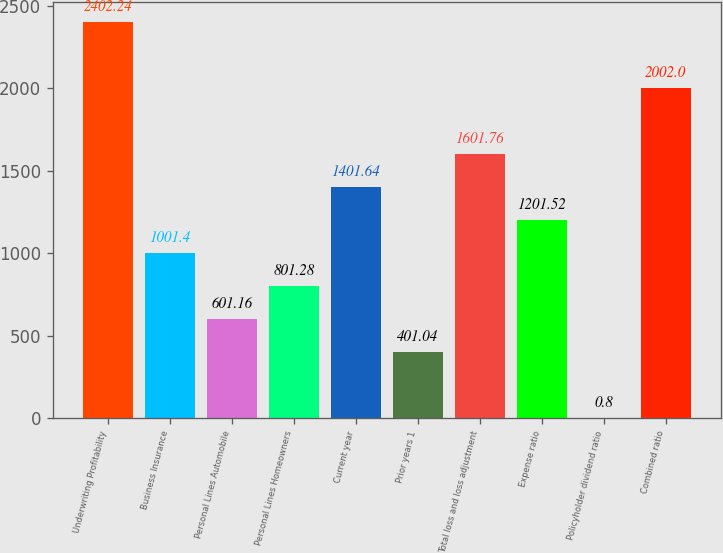Convert chart. <chart><loc_0><loc_0><loc_500><loc_500><bar_chart><fcel>Underwriting Profitability<fcel>Business Insurance<fcel>Personal Lines Automobile<fcel>Personal Lines Homeowners<fcel>Current year<fcel>Prior years 1<fcel>Total loss and loss adjustment<fcel>Expense ratio<fcel>Policyholder dividend ratio<fcel>Combined ratio<nl><fcel>2402.24<fcel>1001.4<fcel>601.16<fcel>801.28<fcel>1401.64<fcel>401.04<fcel>1601.76<fcel>1201.52<fcel>0.8<fcel>2002<nl></chart> 